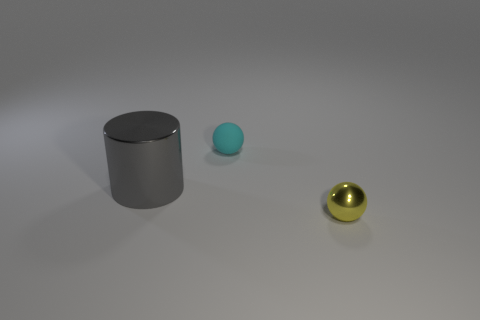There is a matte object that is behind the tiny metallic ball; what shape is it?
Your answer should be compact. Sphere. Is the number of small shiny things that are on the right side of the yellow metallic ball the same as the number of small things that are in front of the tiny cyan ball?
Offer a terse response. No. The thing that is both in front of the cyan rubber ball and to the left of the yellow metallic ball is what color?
Your answer should be very brief. Gray. What is the material of the tiny ball behind the ball that is in front of the big gray object?
Make the answer very short. Rubber. Do the cyan ball and the yellow shiny thing have the same size?
Ensure brevity in your answer.  Yes. How many large objects are purple spheres or metal objects?
Provide a short and direct response. 1. There is a cyan rubber ball; how many objects are left of it?
Ensure brevity in your answer.  1. Is the number of rubber objects that are to the left of the cyan object greater than the number of shiny cylinders?
Your response must be concise. No. There is another thing that is the same material as the large thing; what is its shape?
Provide a short and direct response. Sphere. There is a metallic thing that is in front of the object that is on the left side of the rubber ball; what color is it?
Your answer should be very brief. Yellow. 